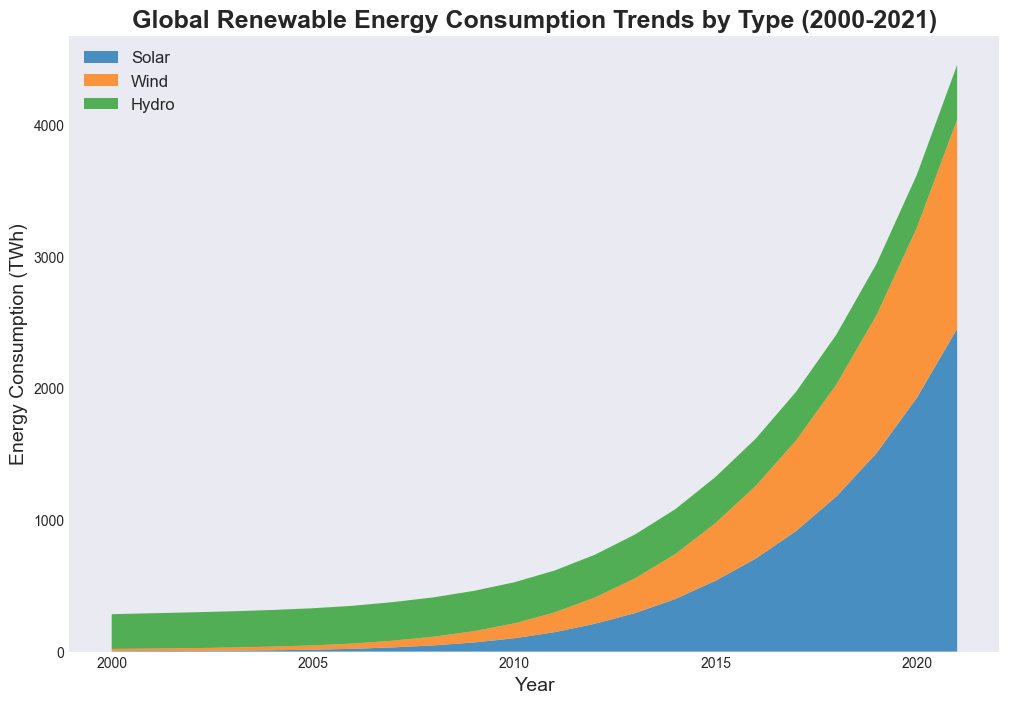What trend is observed in solar energy consumption from 2000 to 2021? Over the years, the area representing solar energy consumption increases significantly, indicating a steep rise in solar energy consumption.
Answer: Increasing Which energy source shows the least growth over the period 2000 to 2021? By comparing the areas, it is noticeable that hydro energy consumption has the least increase and remains relatively steady compared to solar and wind.
Answer: Hydro In what year does wind energy consumption surpass hydro energy consumption? By observing the intersection points, wind energy consumption surpasses hydro energy consumption between 2019 and 2020.
Answer: 2020 What is the approximate difference in energy consumption between solar and wind in 2015? Using the plot, find the values for solar and wind in 2015 (Solar: 538, Wind: 438). The difference is 538 - 438.
Answer: 100 What are the total energy consumption values represented in the figure for the year 2020? Sum the values for solar, wind, and hydro in 2020 (Solar: 1926, Wind: 1292, Hydro: 402). Total is 1926 + 1292 + 402.
Answer: 3620 During which period does solar energy see the most significant increase? The steepest area increase for solar is observed between 2015 and 2021.
Answer: 2015 to 2021 How does the contribution of wind energy in 2005 compare to solar energy in 2010? View the heights of the respective areas at those points. In 2005, wind was at 33 TWh, and in 2010, solar was at 101 TWh - solar in 2010 is significantly higher.
Answer: Solar 2010 is higher What is the combined renewable energy consumption for solar and wind in 2021? Add the values for solar and wind in 2021 (Solar: 2450, Wind: 1588). Total is 2450 + 1588.
Answer: 4038 Which energy type reaches the highest consumption level by 2021? By observing the heights, solar energy reaches the highest level by 2021 compared to wind and hydro.
Answer: Solar Around which year does the total renewable energy consumption start accelerating significantly? The plot shows an accelerating increase from around the year 2010 onwards.
Answer: Around 2010 